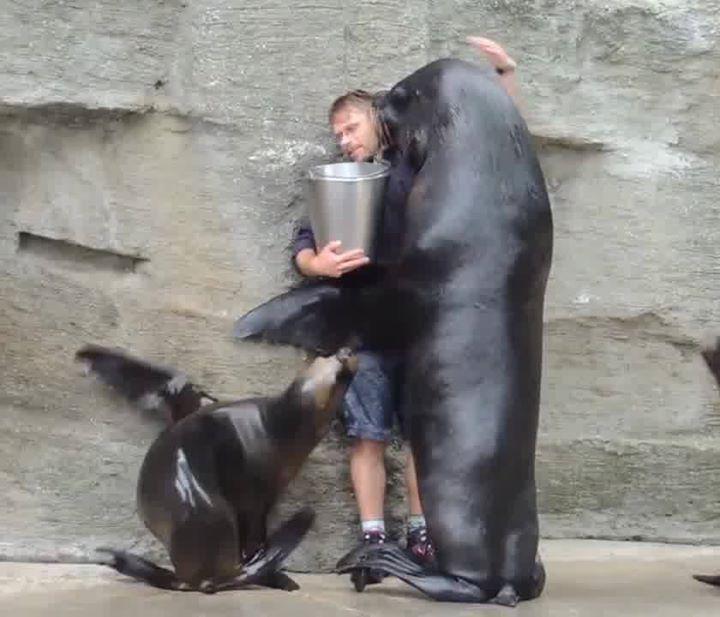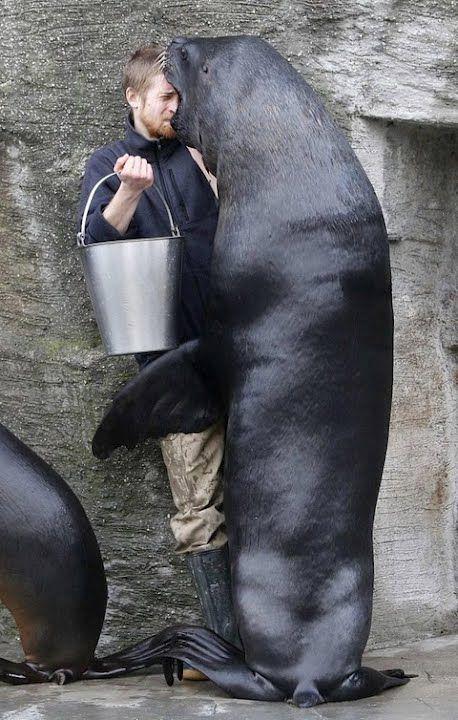The first image is the image on the left, the second image is the image on the right. Evaluate the accuracy of this statement regarding the images: "A man is holding a silver bucket as at least 3 seals gather around him.". Is it true? Answer yes or no. No. The first image is the image on the left, the second image is the image on the right. Assess this claim about the two images: "In both images, an aquarist is being hugged and kissed by a sea lion.". Correct or not? Answer yes or no. Yes. 